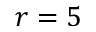Convert formula to latex. <formula><loc_0><loc_0><loc_500><loc_500>r = 5</formula> 